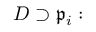Convert formula to latex. <formula><loc_0><loc_0><loc_500><loc_500>D \supset { \mathfrak { p } } _ { i } \colon</formula> 